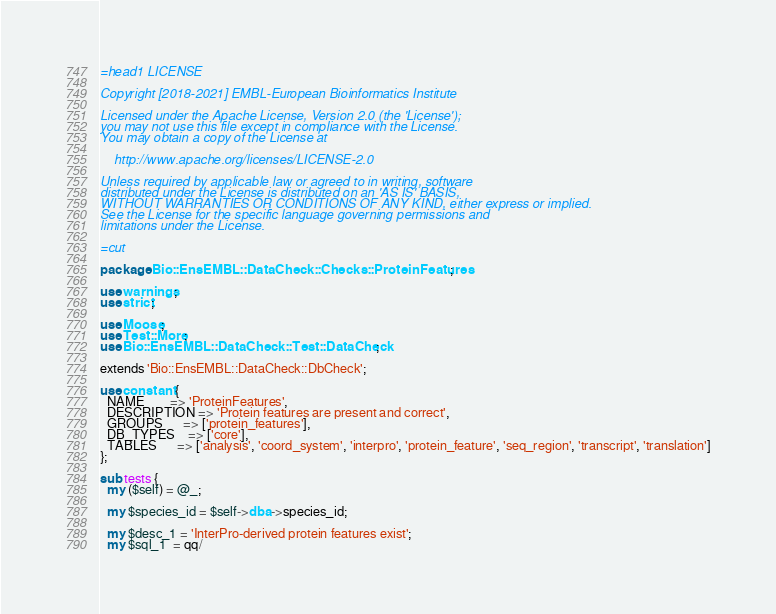Convert code to text. <code><loc_0><loc_0><loc_500><loc_500><_Perl_>=head1 LICENSE

Copyright [2018-2021] EMBL-European Bioinformatics Institute

Licensed under the Apache License, Version 2.0 (the 'License');
you may not use this file except in compliance with the License.
You may obtain a copy of the License at

    http://www.apache.org/licenses/LICENSE-2.0

Unless required by applicable law or agreed to in writing, software
distributed under the License is distributed on an 'AS IS' BASIS,
WITHOUT WARRANTIES OR CONDITIONS OF ANY KIND, either express or implied.
See the License for the specific language governing permissions and
limitations under the License.

=cut

package Bio::EnsEMBL::DataCheck::Checks::ProteinFeatures;

use warnings;
use strict;

use Moose;
use Test::More;
use Bio::EnsEMBL::DataCheck::Test::DataCheck;

extends 'Bio::EnsEMBL::DataCheck::DbCheck';

use constant {
  NAME        => 'ProteinFeatures',
  DESCRIPTION => 'Protein features are present and correct',
  GROUPS      => ['protein_features'],
  DB_TYPES    => ['core'],
  TABLES      => ['analysis', 'coord_system', 'interpro', 'protein_feature', 'seq_region', 'transcript', 'translation']
};

sub tests {
  my ($self) = @_;

  my $species_id = $self->dba->species_id;

  my $desc_1 = 'InterPro-derived protein features exist';
  my $sql_1  = qq/</code> 